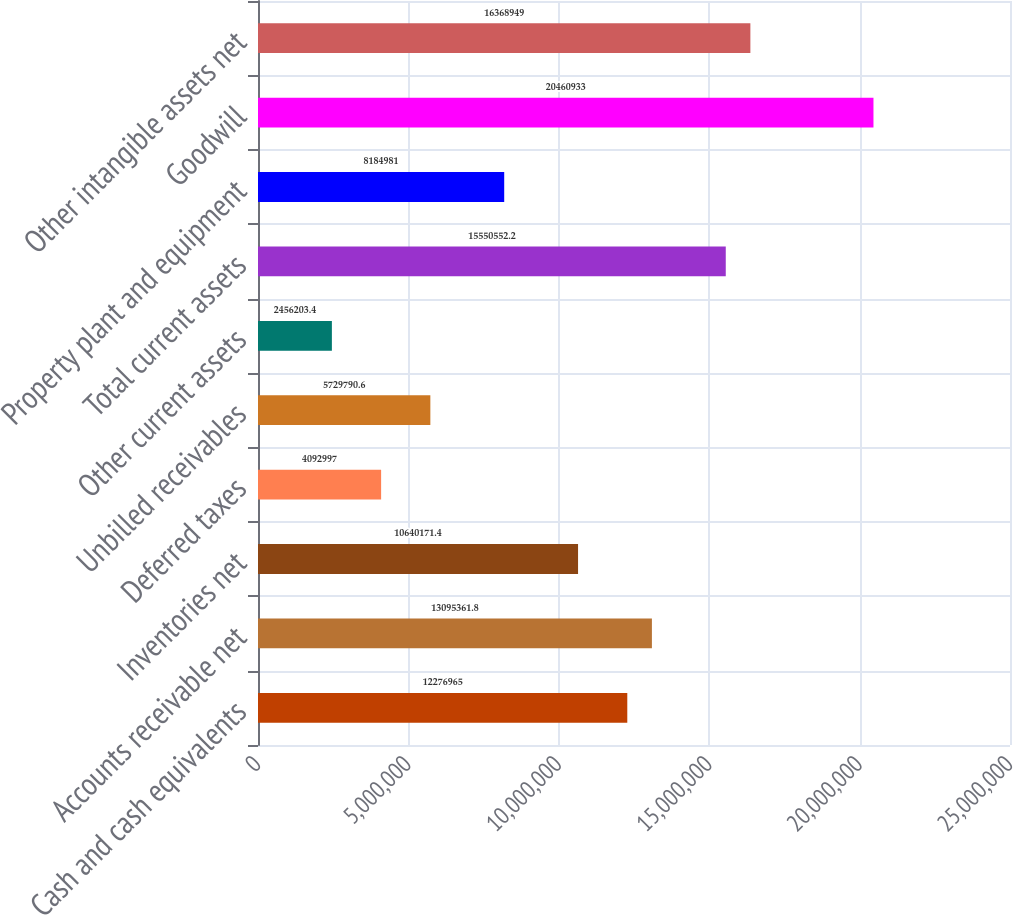Convert chart to OTSL. <chart><loc_0><loc_0><loc_500><loc_500><bar_chart><fcel>Cash and cash equivalents<fcel>Accounts receivable net<fcel>Inventories net<fcel>Deferred taxes<fcel>Unbilled receivables<fcel>Other current assets<fcel>Total current assets<fcel>Property plant and equipment<fcel>Goodwill<fcel>Other intangible assets net<nl><fcel>1.2277e+07<fcel>1.30954e+07<fcel>1.06402e+07<fcel>4.093e+06<fcel>5.72979e+06<fcel>2.4562e+06<fcel>1.55506e+07<fcel>8.18498e+06<fcel>2.04609e+07<fcel>1.63689e+07<nl></chart> 